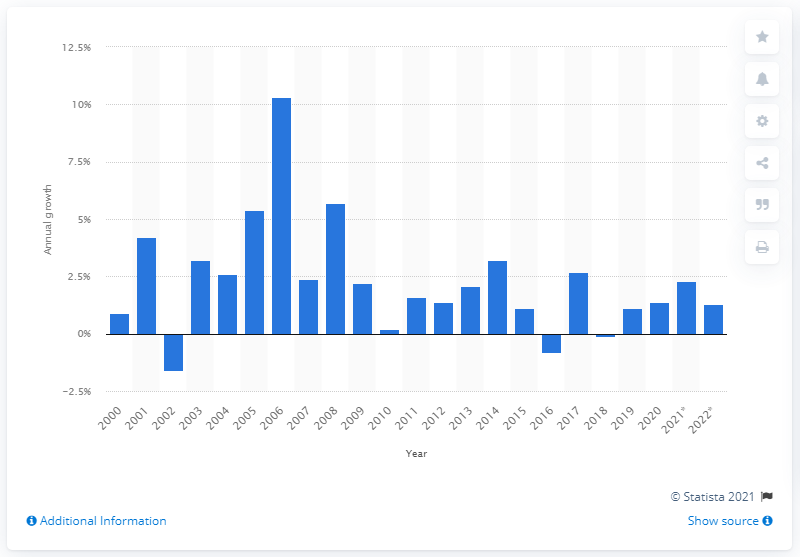Point out several critical features in this image. The residential electricity price is projected to increase by 1.3% between 2021 and 2022. 